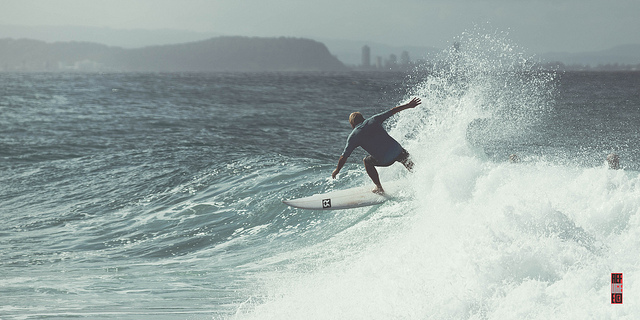<image>What is written on the man's back? I don't know what is written on the man's back. It can be 'o'neil' or nothing. What is written on the man's back? I am not sure what is written on the man's back. It seems like there is nothing written. 